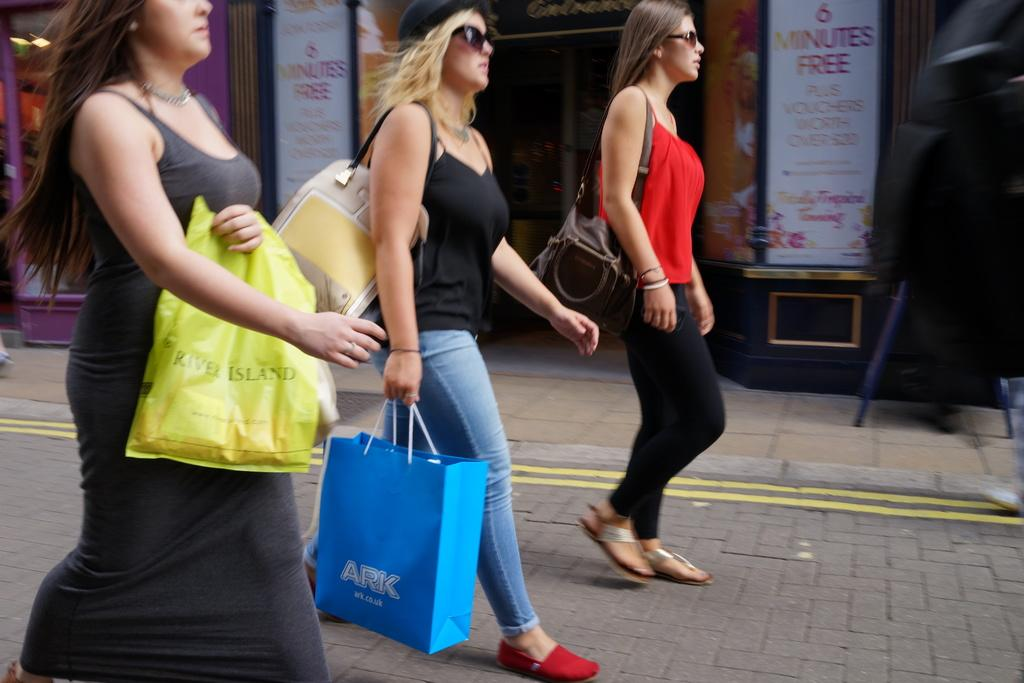Who are the main subjects in the image? There are girls in the center of the image. What can be seen in the background of the image? There are posters and stalls in the background of the image. What type of oven is visible in the image? There is no oven present in the image. 